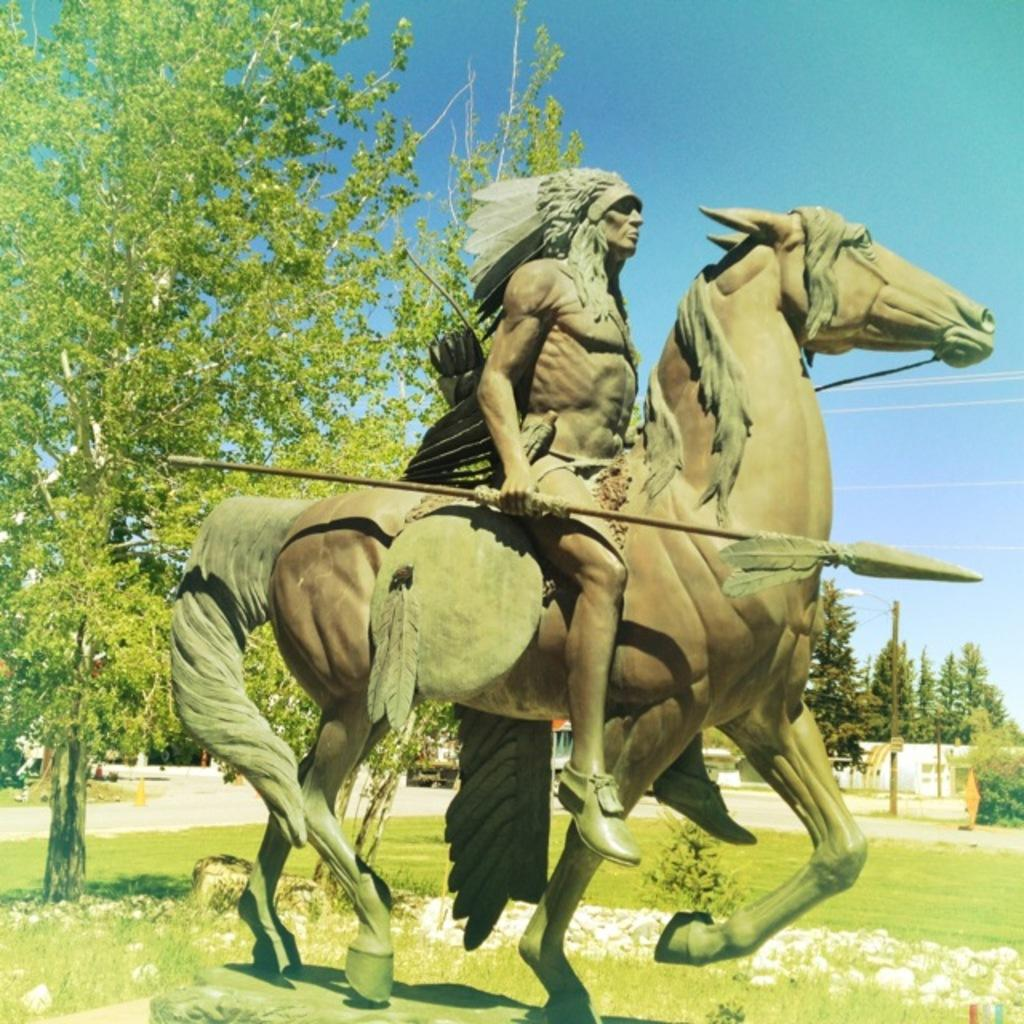What is the main subject of the image? There is a statue of a man and a horse in the image. What can be seen in the background of the image? There are trees in the background of the image. What is the color of the sky in the image? The sky is blue in color. What is the color of the trees in the image? The trees are green in color. Where is the tent located in the image? There is no tent present in the image. What type of underwear is the man wearing in the statue? The statue is not a real person, and therefore the man depicted in the statue is not wearing any underwear. 